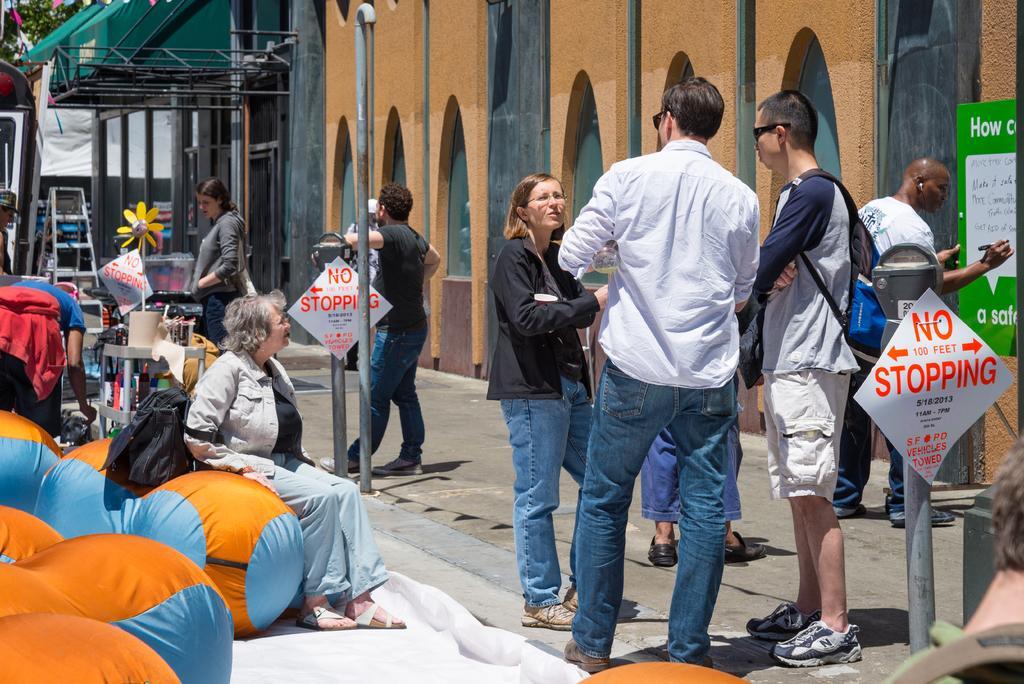Describe this image in one or two sentences. In the image there are few people and on the left side there are some inflatables, there is a woman sitting on one of the inflatable, around the people there are poles, some sheets with text and on the right side there is a man he is writing something on a board, behind the board there is a wall and in the background there are pillars and above the pillars there is a roof. 